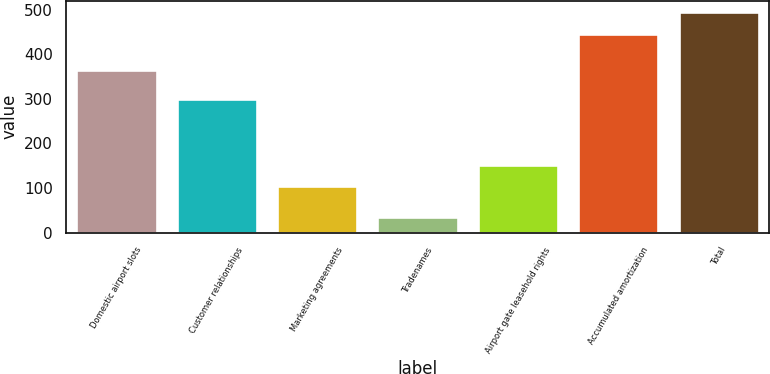Convert chart. <chart><loc_0><loc_0><loc_500><loc_500><bar_chart><fcel>Domestic airport slots<fcel>Customer relationships<fcel>Marketing agreements<fcel>Tradenames<fcel>Airport gate leasehold rights<fcel>Accumulated amortization<fcel>Total<nl><fcel>365<fcel>300<fcel>105<fcel>35<fcel>151.1<fcel>447<fcel>496<nl></chart> 